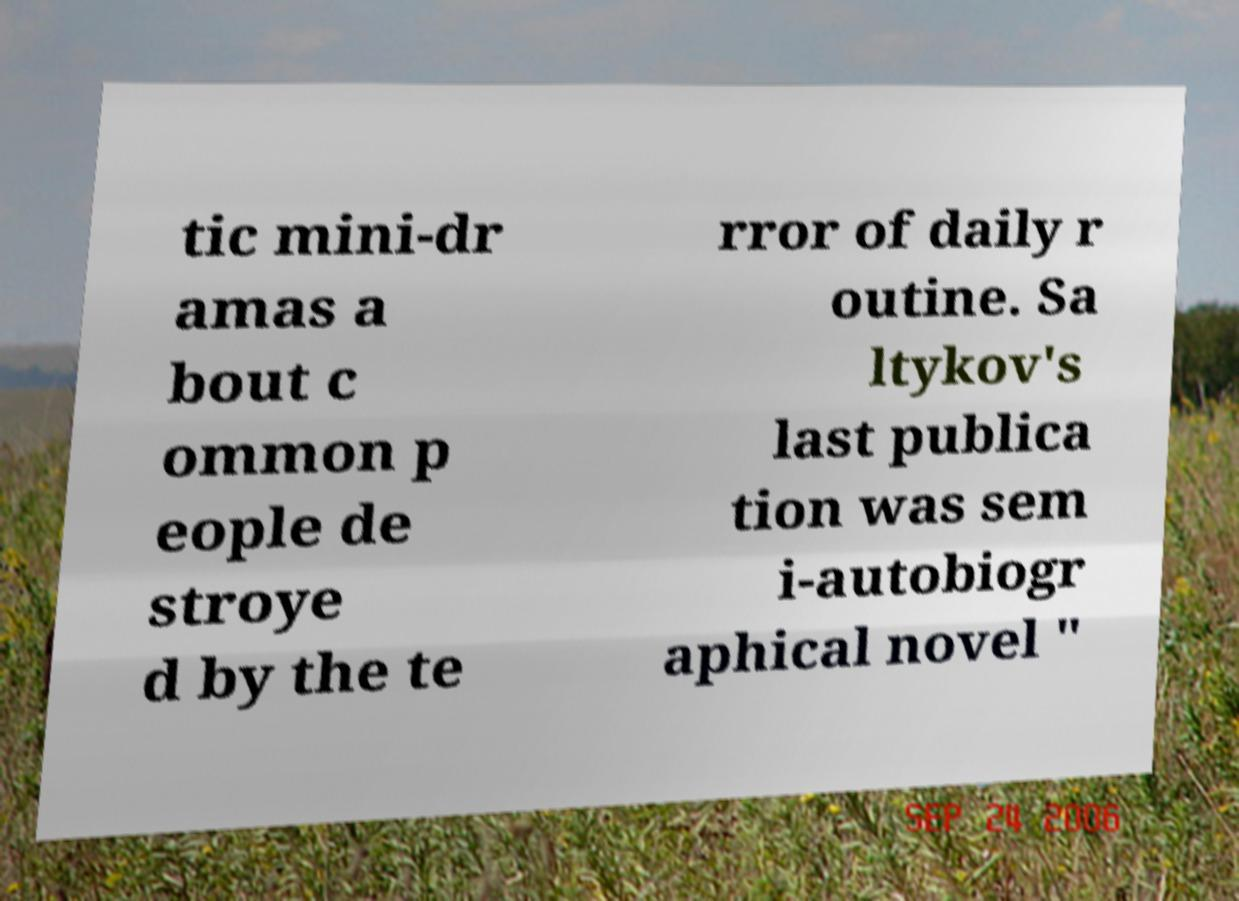Could you assist in decoding the text presented in this image and type it out clearly? tic mini-dr amas a bout c ommon p eople de stroye d by the te rror of daily r outine. Sa ltykov's last publica tion was sem i-autobiogr aphical novel " 